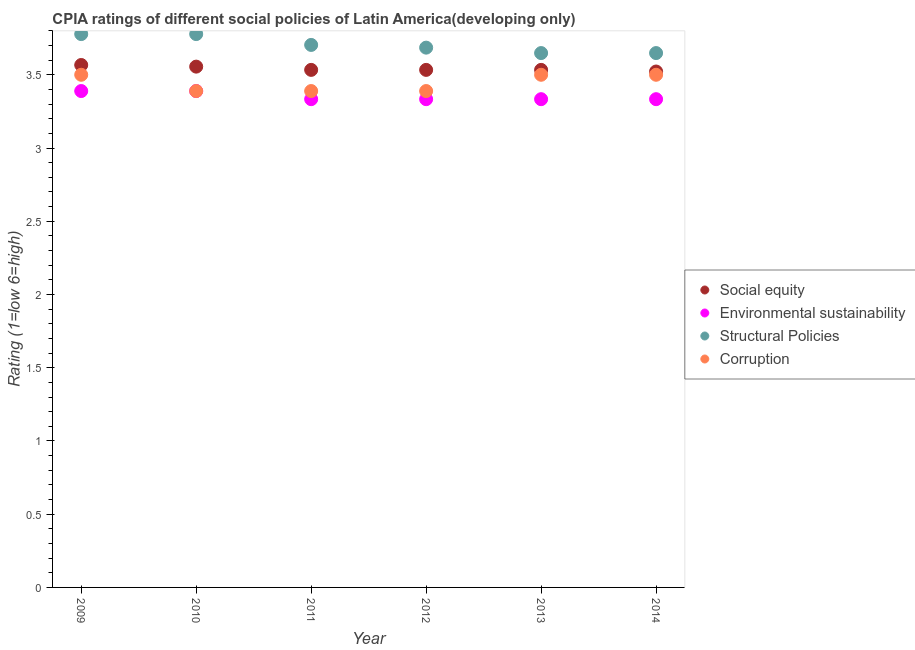Is the number of dotlines equal to the number of legend labels?
Give a very brief answer. Yes. Across all years, what is the maximum cpia rating of corruption?
Give a very brief answer. 3.5. Across all years, what is the minimum cpia rating of structural policies?
Keep it short and to the point. 3.65. In which year was the cpia rating of corruption minimum?
Provide a short and direct response. 2010. What is the total cpia rating of environmental sustainability in the graph?
Offer a terse response. 20.11. What is the difference between the cpia rating of social equity in 2012 and the cpia rating of environmental sustainability in 2009?
Ensure brevity in your answer.  0.14. What is the average cpia rating of social equity per year?
Give a very brief answer. 3.54. In the year 2012, what is the difference between the cpia rating of environmental sustainability and cpia rating of social equity?
Offer a very short reply. -0.2. What is the ratio of the cpia rating of structural policies in 2011 to that in 2013?
Offer a very short reply. 1.02. Is the difference between the cpia rating of corruption in 2012 and 2014 greater than the difference between the cpia rating of social equity in 2012 and 2014?
Your answer should be compact. No. What is the difference between the highest and the second highest cpia rating of corruption?
Your answer should be compact. 0. What is the difference between the highest and the lowest cpia rating of environmental sustainability?
Give a very brief answer. 0.06. In how many years, is the cpia rating of corruption greater than the average cpia rating of corruption taken over all years?
Offer a terse response. 3. Is the sum of the cpia rating of social equity in 2010 and 2011 greater than the maximum cpia rating of structural policies across all years?
Your response must be concise. Yes. Is it the case that in every year, the sum of the cpia rating of structural policies and cpia rating of environmental sustainability is greater than the sum of cpia rating of corruption and cpia rating of social equity?
Give a very brief answer. No. Is it the case that in every year, the sum of the cpia rating of social equity and cpia rating of environmental sustainability is greater than the cpia rating of structural policies?
Make the answer very short. Yes. Is the cpia rating of corruption strictly greater than the cpia rating of social equity over the years?
Ensure brevity in your answer.  No. Is the cpia rating of corruption strictly less than the cpia rating of environmental sustainability over the years?
Offer a very short reply. No. How many years are there in the graph?
Your answer should be very brief. 6. What is the difference between two consecutive major ticks on the Y-axis?
Provide a succinct answer. 0.5. Are the values on the major ticks of Y-axis written in scientific E-notation?
Offer a very short reply. No. How many legend labels are there?
Offer a terse response. 4. What is the title of the graph?
Provide a short and direct response. CPIA ratings of different social policies of Latin America(developing only). Does "United Kingdom" appear as one of the legend labels in the graph?
Keep it short and to the point. No. What is the Rating (1=low 6=high) in Social equity in 2009?
Your answer should be compact. 3.57. What is the Rating (1=low 6=high) in Environmental sustainability in 2009?
Give a very brief answer. 3.39. What is the Rating (1=low 6=high) of Structural Policies in 2009?
Your response must be concise. 3.78. What is the Rating (1=low 6=high) of Social equity in 2010?
Give a very brief answer. 3.56. What is the Rating (1=low 6=high) of Environmental sustainability in 2010?
Keep it short and to the point. 3.39. What is the Rating (1=low 6=high) of Structural Policies in 2010?
Give a very brief answer. 3.78. What is the Rating (1=low 6=high) in Corruption in 2010?
Give a very brief answer. 3.39. What is the Rating (1=low 6=high) in Social equity in 2011?
Your answer should be very brief. 3.53. What is the Rating (1=low 6=high) of Environmental sustainability in 2011?
Your answer should be compact. 3.33. What is the Rating (1=low 6=high) in Structural Policies in 2011?
Ensure brevity in your answer.  3.7. What is the Rating (1=low 6=high) of Corruption in 2011?
Provide a succinct answer. 3.39. What is the Rating (1=low 6=high) in Social equity in 2012?
Give a very brief answer. 3.53. What is the Rating (1=low 6=high) of Environmental sustainability in 2012?
Your answer should be compact. 3.33. What is the Rating (1=low 6=high) in Structural Policies in 2012?
Give a very brief answer. 3.69. What is the Rating (1=low 6=high) of Corruption in 2012?
Your answer should be compact. 3.39. What is the Rating (1=low 6=high) of Social equity in 2013?
Make the answer very short. 3.53. What is the Rating (1=low 6=high) in Environmental sustainability in 2013?
Your answer should be compact. 3.33. What is the Rating (1=low 6=high) in Structural Policies in 2013?
Keep it short and to the point. 3.65. What is the Rating (1=low 6=high) in Corruption in 2013?
Offer a terse response. 3.5. What is the Rating (1=low 6=high) in Social equity in 2014?
Offer a very short reply. 3.52. What is the Rating (1=low 6=high) of Environmental sustainability in 2014?
Make the answer very short. 3.33. What is the Rating (1=low 6=high) of Structural Policies in 2014?
Ensure brevity in your answer.  3.65. Across all years, what is the maximum Rating (1=low 6=high) in Social equity?
Your response must be concise. 3.57. Across all years, what is the maximum Rating (1=low 6=high) of Environmental sustainability?
Provide a short and direct response. 3.39. Across all years, what is the maximum Rating (1=low 6=high) in Structural Policies?
Ensure brevity in your answer.  3.78. Across all years, what is the maximum Rating (1=low 6=high) in Corruption?
Your answer should be very brief. 3.5. Across all years, what is the minimum Rating (1=low 6=high) of Social equity?
Provide a succinct answer. 3.52. Across all years, what is the minimum Rating (1=low 6=high) of Environmental sustainability?
Your answer should be compact. 3.33. Across all years, what is the minimum Rating (1=low 6=high) of Structural Policies?
Your response must be concise. 3.65. Across all years, what is the minimum Rating (1=low 6=high) in Corruption?
Your response must be concise. 3.39. What is the total Rating (1=low 6=high) of Social equity in the graph?
Provide a short and direct response. 21.24. What is the total Rating (1=low 6=high) in Environmental sustainability in the graph?
Give a very brief answer. 20.11. What is the total Rating (1=low 6=high) of Structural Policies in the graph?
Give a very brief answer. 22.24. What is the total Rating (1=low 6=high) of Corruption in the graph?
Make the answer very short. 20.67. What is the difference between the Rating (1=low 6=high) of Social equity in 2009 and that in 2010?
Your response must be concise. 0.01. What is the difference between the Rating (1=low 6=high) in Structural Policies in 2009 and that in 2010?
Offer a terse response. 0. What is the difference between the Rating (1=low 6=high) in Corruption in 2009 and that in 2010?
Keep it short and to the point. 0.11. What is the difference between the Rating (1=low 6=high) in Social equity in 2009 and that in 2011?
Ensure brevity in your answer.  0.03. What is the difference between the Rating (1=low 6=high) in Environmental sustainability in 2009 and that in 2011?
Your answer should be very brief. 0.06. What is the difference between the Rating (1=low 6=high) of Structural Policies in 2009 and that in 2011?
Make the answer very short. 0.07. What is the difference between the Rating (1=low 6=high) of Social equity in 2009 and that in 2012?
Your response must be concise. 0.03. What is the difference between the Rating (1=low 6=high) in Environmental sustainability in 2009 and that in 2012?
Offer a very short reply. 0.06. What is the difference between the Rating (1=low 6=high) in Structural Policies in 2009 and that in 2012?
Ensure brevity in your answer.  0.09. What is the difference between the Rating (1=low 6=high) of Environmental sustainability in 2009 and that in 2013?
Provide a short and direct response. 0.06. What is the difference between the Rating (1=low 6=high) in Structural Policies in 2009 and that in 2013?
Your answer should be very brief. 0.13. What is the difference between the Rating (1=low 6=high) in Social equity in 2009 and that in 2014?
Ensure brevity in your answer.  0.04. What is the difference between the Rating (1=low 6=high) in Environmental sustainability in 2009 and that in 2014?
Give a very brief answer. 0.06. What is the difference between the Rating (1=low 6=high) of Structural Policies in 2009 and that in 2014?
Give a very brief answer. 0.13. What is the difference between the Rating (1=low 6=high) of Corruption in 2009 and that in 2014?
Offer a terse response. 0. What is the difference between the Rating (1=low 6=high) of Social equity in 2010 and that in 2011?
Offer a terse response. 0.02. What is the difference between the Rating (1=low 6=high) of Environmental sustainability in 2010 and that in 2011?
Make the answer very short. 0.06. What is the difference between the Rating (1=low 6=high) in Structural Policies in 2010 and that in 2011?
Provide a short and direct response. 0.07. What is the difference between the Rating (1=low 6=high) of Corruption in 2010 and that in 2011?
Your response must be concise. 0. What is the difference between the Rating (1=low 6=high) of Social equity in 2010 and that in 2012?
Your response must be concise. 0.02. What is the difference between the Rating (1=low 6=high) of Environmental sustainability in 2010 and that in 2012?
Provide a succinct answer. 0.06. What is the difference between the Rating (1=low 6=high) in Structural Policies in 2010 and that in 2012?
Give a very brief answer. 0.09. What is the difference between the Rating (1=low 6=high) of Corruption in 2010 and that in 2012?
Provide a succinct answer. 0. What is the difference between the Rating (1=low 6=high) in Social equity in 2010 and that in 2013?
Make the answer very short. 0.02. What is the difference between the Rating (1=low 6=high) of Environmental sustainability in 2010 and that in 2013?
Keep it short and to the point. 0.06. What is the difference between the Rating (1=low 6=high) in Structural Policies in 2010 and that in 2013?
Ensure brevity in your answer.  0.13. What is the difference between the Rating (1=low 6=high) of Corruption in 2010 and that in 2013?
Offer a very short reply. -0.11. What is the difference between the Rating (1=low 6=high) of Environmental sustainability in 2010 and that in 2014?
Provide a succinct answer. 0.06. What is the difference between the Rating (1=low 6=high) in Structural Policies in 2010 and that in 2014?
Your answer should be very brief. 0.13. What is the difference between the Rating (1=low 6=high) of Corruption in 2010 and that in 2014?
Provide a succinct answer. -0.11. What is the difference between the Rating (1=low 6=high) in Structural Policies in 2011 and that in 2012?
Ensure brevity in your answer.  0.02. What is the difference between the Rating (1=low 6=high) in Social equity in 2011 and that in 2013?
Offer a terse response. 0. What is the difference between the Rating (1=low 6=high) of Structural Policies in 2011 and that in 2013?
Provide a short and direct response. 0.06. What is the difference between the Rating (1=low 6=high) in Corruption in 2011 and that in 2013?
Keep it short and to the point. -0.11. What is the difference between the Rating (1=low 6=high) in Social equity in 2011 and that in 2014?
Your response must be concise. 0.01. What is the difference between the Rating (1=low 6=high) of Structural Policies in 2011 and that in 2014?
Offer a very short reply. 0.06. What is the difference between the Rating (1=low 6=high) of Corruption in 2011 and that in 2014?
Your answer should be very brief. -0.11. What is the difference between the Rating (1=low 6=high) in Environmental sustainability in 2012 and that in 2013?
Your answer should be very brief. 0. What is the difference between the Rating (1=low 6=high) of Structural Policies in 2012 and that in 2013?
Keep it short and to the point. 0.04. What is the difference between the Rating (1=low 6=high) of Corruption in 2012 and that in 2013?
Your response must be concise. -0.11. What is the difference between the Rating (1=low 6=high) of Social equity in 2012 and that in 2014?
Keep it short and to the point. 0.01. What is the difference between the Rating (1=low 6=high) of Structural Policies in 2012 and that in 2014?
Keep it short and to the point. 0.04. What is the difference between the Rating (1=low 6=high) in Corruption in 2012 and that in 2014?
Your answer should be very brief. -0.11. What is the difference between the Rating (1=low 6=high) of Social equity in 2013 and that in 2014?
Offer a very short reply. 0.01. What is the difference between the Rating (1=low 6=high) in Environmental sustainability in 2013 and that in 2014?
Offer a terse response. 0. What is the difference between the Rating (1=low 6=high) of Corruption in 2013 and that in 2014?
Offer a terse response. 0. What is the difference between the Rating (1=low 6=high) in Social equity in 2009 and the Rating (1=low 6=high) in Environmental sustainability in 2010?
Provide a short and direct response. 0.18. What is the difference between the Rating (1=low 6=high) of Social equity in 2009 and the Rating (1=low 6=high) of Structural Policies in 2010?
Your answer should be compact. -0.21. What is the difference between the Rating (1=low 6=high) of Social equity in 2009 and the Rating (1=low 6=high) of Corruption in 2010?
Offer a very short reply. 0.18. What is the difference between the Rating (1=low 6=high) of Environmental sustainability in 2009 and the Rating (1=low 6=high) of Structural Policies in 2010?
Provide a succinct answer. -0.39. What is the difference between the Rating (1=low 6=high) in Structural Policies in 2009 and the Rating (1=low 6=high) in Corruption in 2010?
Make the answer very short. 0.39. What is the difference between the Rating (1=low 6=high) in Social equity in 2009 and the Rating (1=low 6=high) in Environmental sustainability in 2011?
Make the answer very short. 0.23. What is the difference between the Rating (1=low 6=high) of Social equity in 2009 and the Rating (1=low 6=high) of Structural Policies in 2011?
Your response must be concise. -0.14. What is the difference between the Rating (1=low 6=high) in Social equity in 2009 and the Rating (1=low 6=high) in Corruption in 2011?
Keep it short and to the point. 0.18. What is the difference between the Rating (1=low 6=high) of Environmental sustainability in 2009 and the Rating (1=low 6=high) of Structural Policies in 2011?
Give a very brief answer. -0.31. What is the difference between the Rating (1=low 6=high) in Structural Policies in 2009 and the Rating (1=low 6=high) in Corruption in 2011?
Your response must be concise. 0.39. What is the difference between the Rating (1=low 6=high) in Social equity in 2009 and the Rating (1=low 6=high) in Environmental sustainability in 2012?
Offer a terse response. 0.23. What is the difference between the Rating (1=low 6=high) in Social equity in 2009 and the Rating (1=low 6=high) in Structural Policies in 2012?
Your answer should be very brief. -0.12. What is the difference between the Rating (1=low 6=high) in Social equity in 2009 and the Rating (1=low 6=high) in Corruption in 2012?
Provide a short and direct response. 0.18. What is the difference between the Rating (1=low 6=high) in Environmental sustainability in 2009 and the Rating (1=low 6=high) in Structural Policies in 2012?
Offer a very short reply. -0.3. What is the difference between the Rating (1=low 6=high) of Structural Policies in 2009 and the Rating (1=low 6=high) of Corruption in 2012?
Offer a very short reply. 0.39. What is the difference between the Rating (1=low 6=high) of Social equity in 2009 and the Rating (1=low 6=high) of Environmental sustainability in 2013?
Offer a terse response. 0.23. What is the difference between the Rating (1=low 6=high) of Social equity in 2009 and the Rating (1=low 6=high) of Structural Policies in 2013?
Offer a very short reply. -0.08. What is the difference between the Rating (1=low 6=high) of Social equity in 2009 and the Rating (1=low 6=high) of Corruption in 2013?
Your answer should be very brief. 0.07. What is the difference between the Rating (1=low 6=high) in Environmental sustainability in 2009 and the Rating (1=low 6=high) in Structural Policies in 2013?
Your response must be concise. -0.26. What is the difference between the Rating (1=low 6=high) of Environmental sustainability in 2009 and the Rating (1=low 6=high) of Corruption in 2013?
Provide a short and direct response. -0.11. What is the difference between the Rating (1=low 6=high) in Structural Policies in 2009 and the Rating (1=low 6=high) in Corruption in 2013?
Offer a terse response. 0.28. What is the difference between the Rating (1=low 6=high) of Social equity in 2009 and the Rating (1=low 6=high) of Environmental sustainability in 2014?
Keep it short and to the point. 0.23. What is the difference between the Rating (1=low 6=high) of Social equity in 2009 and the Rating (1=low 6=high) of Structural Policies in 2014?
Your response must be concise. -0.08. What is the difference between the Rating (1=low 6=high) in Social equity in 2009 and the Rating (1=low 6=high) in Corruption in 2014?
Ensure brevity in your answer.  0.07. What is the difference between the Rating (1=low 6=high) in Environmental sustainability in 2009 and the Rating (1=low 6=high) in Structural Policies in 2014?
Provide a succinct answer. -0.26. What is the difference between the Rating (1=low 6=high) of Environmental sustainability in 2009 and the Rating (1=low 6=high) of Corruption in 2014?
Your answer should be very brief. -0.11. What is the difference between the Rating (1=low 6=high) of Structural Policies in 2009 and the Rating (1=low 6=high) of Corruption in 2014?
Give a very brief answer. 0.28. What is the difference between the Rating (1=low 6=high) of Social equity in 2010 and the Rating (1=low 6=high) of Environmental sustainability in 2011?
Your answer should be very brief. 0.22. What is the difference between the Rating (1=low 6=high) of Social equity in 2010 and the Rating (1=low 6=high) of Structural Policies in 2011?
Ensure brevity in your answer.  -0.15. What is the difference between the Rating (1=low 6=high) of Social equity in 2010 and the Rating (1=low 6=high) of Corruption in 2011?
Provide a succinct answer. 0.17. What is the difference between the Rating (1=low 6=high) of Environmental sustainability in 2010 and the Rating (1=low 6=high) of Structural Policies in 2011?
Your answer should be compact. -0.31. What is the difference between the Rating (1=low 6=high) of Environmental sustainability in 2010 and the Rating (1=low 6=high) of Corruption in 2011?
Ensure brevity in your answer.  0. What is the difference between the Rating (1=low 6=high) in Structural Policies in 2010 and the Rating (1=low 6=high) in Corruption in 2011?
Your answer should be very brief. 0.39. What is the difference between the Rating (1=low 6=high) of Social equity in 2010 and the Rating (1=low 6=high) of Environmental sustainability in 2012?
Keep it short and to the point. 0.22. What is the difference between the Rating (1=low 6=high) of Social equity in 2010 and the Rating (1=low 6=high) of Structural Policies in 2012?
Your response must be concise. -0.13. What is the difference between the Rating (1=low 6=high) of Environmental sustainability in 2010 and the Rating (1=low 6=high) of Structural Policies in 2012?
Give a very brief answer. -0.3. What is the difference between the Rating (1=low 6=high) of Structural Policies in 2010 and the Rating (1=low 6=high) of Corruption in 2012?
Keep it short and to the point. 0.39. What is the difference between the Rating (1=low 6=high) of Social equity in 2010 and the Rating (1=low 6=high) of Environmental sustainability in 2013?
Provide a short and direct response. 0.22. What is the difference between the Rating (1=low 6=high) in Social equity in 2010 and the Rating (1=low 6=high) in Structural Policies in 2013?
Keep it short and to the point. -0.09. What is the difference between the Rating (1=low 6=high) of Social equity in 2010 and the Rating (1=low 6=high) of Corruption in 2013?
Give a very brief answer. 0.06. What is the difference between the Rating (1=low 6=high) of Environmental sustainability in 2010 and the Rating (1=low 6=high) of Structural Policies in 2013?
Ensure brevity in your answer.  -0.26. What is the difference between the Rating (1=low 6=high) of Environmental sustainability in 2010 and the Rating (1=low 6=high) of Corruption in 2013?
Offer a very short reply. -0.11. What is the difference between the Rating (1=low 6=high) in Structural Policies in 2010 and the Rating (1=low 6=high) in Corruption in 2013?
Make the answer very short. 0.28. What is the difference between the Rating (1=low 6=high) of Social equity in 2010 and the Rating (1=low 6=high) of Environmental sustainability in 2014?
Ensure brevity in your answer.  0.22. What is the difference between the Rating (1=low 6=high) in Social equity in 2010 and the Rating (1=low 6=high) in Structural Policies in 2014?
Provide a succinct answer. -0.09. What is the difference between the Rating (1=low 6=high) in Social equity in 2010 and the Rating (1=low 6=high) in Corruption in 2014?
Provide a succinct answer. 0.06. What is the difference between the Rating (1=low 6=high) in Environmental sustainability in 2010 and the Rating (1=low 6=high) in Structural Policies in 2014?
Provide a succinct answer. -0.26. What is the difference between the Rating (1=low 6=high) in Environmental sustainability in 2010 and the Rating (1=low 6=high) in Corruption in 2014?
Make the answer very short. -0.11. What is the difference between the Rating (1=low 6=high) of Structural Policies in 2010 and the Rating (1=low 6=high) of Corruption in 2014?
Offer a very short reply. 0.28. What is the difference between the Rating (1=low 6=high) of Social equity in 2011 and the Rating (1=low 6=high) of Structural Policies in 2012?
Your response must be concise. -0.15. What is the difference between the Rating (1=low 6=high) of Social equity in 2011 and the Rating (1=low 6=high) of Corruption in 2012?
Your answer should be compact. 0.14. What is the difference between the Rating (1=low 6=high) of Environmental sustainability in 2011 and the Rating (1=low 6=high) of Structural Policies in 2012?
Your response must be concise. -0.35. What is the difference between the Rating (1=low 6=high) in Environmental sustainability in 2011 and the Rating (1=low 6=high) in Corruption in 2012?
Make the answer very short. -0.06. What is the difference between the Rating (1=low 6=high) of Structural Policies in 2011 and the Rating (1=low 6=high) of Corruption in 2012?
Provide a succinct answer. 0.31. What is the difference between the Rating (1=low 6=high) in Social equity in 2011 and the Rating (1=low 6=high) in Structural Policies in 2013?
Offer a very short reply. -0.11. What is the difference between the Rating (1=low 6=high) of Social equity in 2011 and the Rating (1=low 6=high) of Corruption in 2013?
Ensure brevity in your answer.  0.03. What is the difference between the Rating (1=low 6=high) of Environmental sustainability in 2011 and the Rating (1=low 6=high) of Structural Policies in 2013?
Give a very brief answer. -0.31. What is the difference between the Rating (1=low 6=high) of Structural Policies in 2011 and the Rating (1=low 6=high) of Corruption in 2013?
Your answer should be very brief. 0.2. What is the difference between the Rating (1=low 6=high) in Social equity in 2011 and the Rating (1=low 6=high) in Environmental sustainability in 2014?
Make the answer very short. 0.2. What is the difference between the Rating (1=low 6=high) of Social equity in 2011 and the Rating (1=low 6=high) of Structural Policies in 2014?
Keep it short and to the point. -0.11. What is the difference between the Rating (1=low 6=high) in Social equity in 2011 and the Rating (1=low 6=high) in Corruption in 2014?
Make the answer very short. 0.03. What is the difference between the Rating (1=low 6=high) of Environmental sustainability in 2011 and the Rating (1=low 6=high) of Structural Policies in 2014?
Offer a terse response. -0.31. What is the difference between the Rating (1=low 6=high) in Structural Policies in 2011 and the Rating (1=low 6=high) in Corruption in 2014?
Keep it short and to the point. 0.2. What is the difference between the Rating (1=low 6=high) of Social equity in 2012 and the Rating (1=low 6=high) of Structural Policies in 2013?
Keep it short and to the point. -0.11. What is the difference between the Rating (1=low 6=high) of Social equity in 2012 and the Rating (1=low 6=high) of Corruption in 2013?
Your answer should be very brief. 0.03. What is the difference between the Rating (1=low 6=high) of Environmental sustainability in 2012 and the Rating (1=low 6=high) of Structural Policies in 2013?
Your answer should be compact. -0.31. What is the difference between the Rating (1=low 6=high) in Environmental sustainability in 2012 and the Rating (1=low 6=high) in Corruption in 2013?
Your answer should be compact. -0.17. What is the difference between the Rating (1=low 6=high) in Structural Policies in 2012 and the Rating (1=low 6=high) in Corruption in 2013?
Make the answer very short. 0.19. What is the difference between the Rating (1=low 6=high) of Social equity in 2012 and the Rating (1=low 6=high) of Structural Policies in 2014?
Provide a succinct answer. -0.11. What is the difference between the Rating (1=low 6=high) of Social equity in 2012 and the Rating (1=low 6=high) of Corruption in 2014?
Offer a terse response. 0.03. What is the difference between the Rating (1=low 6=high) in Environmental sustainability in 2012 and the Rating (1=low 6=high) in Structural Policies in 2014?
Provide a succinct answer. -0.31. What is the difference between the Rating (1=low 6=high) in Structural Policies in 2012 and the Rating (1=low 6=high) in Corruption in 2014?
Give a very brief answer. 0.19. What is the difference between the Rating (1=low 6=high) of Social equity in 2013 and the Rating (1=low 6=high) of Environmental sustainability in 2014?
Your answer should be very brief. 0.2. What is the difference between the Rating (1=low 6=high) in Social equity in 2013 and the Rating (1=low 6=high) in Structural Policies in 2014?
Ensure brevity in your answer.  -0.11. What is the difference between the Rating (1=low 6=high) of Environmental sustainability in 2013 and the Rating (1=low 6=high) of Structural Policies in 2014?
Keep it short and to the point. -0.31. What is the difference between the Rating (1=low 6=high) in Structural Policies in 2013 and the Rating (1=low 6=high) in Corruption in 2014?
Provide a short and direct response. 0.15. What is the average Rating (1=low 6=high) in Social equity per year?
Your response must be concise. 3.54. What is the average Rating (1=low 6=high) in Environmental sustainability per year?
Ensure brevity in your answer.  3.35. What is the average Rating (1=low 6=high) in Structural Policies per year?
Your answer should be very brief. 3.71. What is the average Rating (1=low 6=high) in Corruption per year?
Your answer should be compact. 3.44. In the year 2009, what is the difference between the Rating (1=low 6=high) of Social equity and Rating (1=low 6=high) of Environmental sustainability?
Offer a very short reply. 0.18. In the year 2009, what is the difference between the Rating (1=low 6=high) of Social equity and Rating (1=low 6=high) of Structural Policies?
Your answer should be very brief. -0.21. In the year 2009, what is the difference between the Rating (1=low 6=high) in Social equity and Rating (1=low 6=high) in Corruption?
Provide a succinct answer. 0.07. In the year 2009, what is the difference between the Rating (1=low 6=high) of Environmental sustainability and Rating (1=low 6=high) of Structural Policies?
Your answer should be very brief. -0.39. In the year 2009, what is the difference between the Rating (1=low 6=high) in Environmental sustainability and Rating (1=low 6=high) in Corruption?
Make the answer very short. -0.11. In the year 2009, what is the difference between the Rating (1=low 6=high) of Structural Policies and Rating (1=low 6=high) of Corruption?
Provide a succinct answer. 0.28. In the year 2010, what is the difference between the Rating (1=low 6=high) in Social equity and Rating (1=low 6=high) in Environmental sustainability?
Provide a succinct answer. 0.17. In the year 2010, what is the difference between the Rating (1=low 6=high) in Social equity and Rating (1=low 6=high) in Structural Policies?
Your response must be concise. -0.22. In the year 2010, what is the difference between the Rating (1=low 6=high) of Social equity and Rating (1=low 6=high) of Corruption?
Offer a terse response. 0.17. In the year 2010, what is the difference between the Rating (1=low 6=high) of Environmental sustainability and Rating (1=low 6=high) of Structural Policies?
Make the answer very short. -0.39. In the year 2010, what is the difference between the Rating (1=low 6=high) of Environmental sustainability and Rating (1=low 6=high) of Corruption?
Your response must be concise. 0. In the year 2010, what is the difference between the Rating (1=low 6=high) of Structural Policies and Rating (1=low 6=high) of Corruption?
Your answer should be very brief. 0.39. In the year 2011, what is the difference between the Rating (1=low 6=high) in Social equity and Rating (1=low 6=high) in Structural Policies?
Ensure brevity in your answer.  -0.17. In the year 2011, what is the difference between the Rating (1=low 6=high) of Social equity and Rating (1=low 6=high) of Corruption?
Offer a terse response. 0.14. In the year 2011, what is the difference between the Rating (1=low 6=high) in Environmental sustainability and Rating (1=low 6=high) in Structural Policies?
Your answer should be compact. -0.37. In the year 2011, what is the difference between the Rating (1=low 6=high) of Environmental sustainability and Rating (1=low 6=high) of Corruption?
Provide a short and direct response. -0.06. In the year 2011, what is the difference between the Rating (1=low 6=high) in Structural Policies and Rating (1=low 6=high) in Corruption?
Keep it short and to the point. 0.31. In the year 2012, what is the difference between the Rating (1=low 6=high) of Social equity and Rating (1=low 6=high) of Structural Policies?
Give a very brief answer. -0.15. In the year 2012, what is the difference between the Rating (1=low 6=high) in Social equity and Rating (1=low 6=high) in Corruption?
Your answer should be compact. 0.14. In the year 2012, what is the difference between the Rating (1=low 6=high) of Environmental sustainability and Rating (1=low 6=high) of Structural Policies?
Offer a very short reply. -0.35. In the year 2012, what is the difference between the Rating (1=low 6=high) of Environmental sustainability and Rating (1=low 6=high) of Corruption?
Provide a succinct answer. -0.06. In the year 2012, what is the difference between the Rating (1=low 6=high) in Structural Policies and Rating (1=low 6=high) in Corruption?
Your answer should be compact. 0.3. In the year 2013, what is the difference between the Rating (1=low 6=high) in Social equity and Rating (1=low 6=high) in Environmental sustainability?
Provide a short and direct response. 0.2. In the year 2013, what is the difference between the Rating (1=low 6=high) in Social equity and Rating (1=low 6=high) in Structural Policies?
Offer a very short reply. -0.11. In the year 2013, what is the difference between the Rating (1=low 6=high) in Environmental sustainability and Rating (1=low 6=high) in Structural Policies?
Make the answer very short. -0.31. In the year 2013, what is the difference between the Rating (1=low 6=high) of Structural Policies and Rating (1=low 6=high) of Corruption?
Your response must be concise. 0.15. In the year 2014, what is the difference between the Rating (1=low 6=high) in Social equity and Rating (1=low 6=high) in Environmental sustainability?
Make the answer very short. 0.19. In the year 2014, what is the difference between the Rating (1=low 6=high) of Social equity and Rating (1=low 6=high) of Structural Policies?
Your answer should be very brief. -0.13. In the year 2014, what is the difference between the Rating (1=low 6=high) in Social equity and Rating (1=low 6=high) in Corruption?
Provide a short and direct response. 0.02. In the year 2014, what is the difference between the Rating (1=low 6=high) in Environmental sustainability and Rating (1=low 6=high) in Structural Policies?
Offer a very short reply. -0.31. In the year 2014, what is the difference between the Rating (1=low 6=high) in Environmental sustainability and Rating (1=low 6=high) in Corruption?
Make the answer very short. -0.17. In the year 2014, what is the difference between the Rating (1=low 6=high) in Structural Policies and Rating (1=low 6=high) in Corruption?
Provide a succinct answer. 0.15. What is the ratio of the Rating (1=low 6=high) of Social equity in 2009 to that in 2010?
Offer a terse response. 1. What is the ratio of the Rating (1=low 6=high) of Corruption in 2009 to that in 2010?
Make the answer very short. 1.03. What is the ratio of the Rating (1=low 6=high) of Social equity in 2009 to that in 2011?
Your answer should be very brief. 1.01. What is the ratio of the Rating (1=low 6=high) of Environmental sustainability in 2009 to that in 2011?
Offer a terse response. 1.02. What is the ratio of the Rating (1=low 6=high) in Corruption in 2009 to that in 2011?
Your answer should be very brief. 1.03. What is the ratio of the Rating (1=low 6=high) in Social equity in 2009 to that in 2012?
Make the answer very short. 1.01. What is the ratio of the Rating (1=low 6=high) of Environmental sustainability in 2009 to that in 2012?
Ensure brevity in your answer.  1.02. What is the ratio of the Rating (1=low 6=high) of Structural Policies in 2009 to that in 2012?
Give a very brief answer. 1.03. What is the ratio of the Rating (1=low 6=high) of Corruption in 2009 to that in 2012?
Provide a succinct answer. 1.03. What is the ratio of the Rating (1=low 6=high) of Social equity in 2009 to that in 2013?
Offer a very short reply. 1.01. What is the ratio of the Rating (1=low 6=high) in Environmental sustainability in 2009 to that in 2013?
Your response must be concise. 1.02. What is the ratio of the Rating (1=low 6=high) in Structural Policies in 2009 to that in 2013?
Make the answer very short. 1.04. What is the ratio of the Rating (1=low 6=high) in Corruption in 2009 to that in 2013?
Your answer should be very brief. 1. What is the ratio of the Rating (1=low 6=high) of Social equity in 2009 to that in 2014?
Your answer should be compact. 1.01. What is the ratio of the Rating (1=low 6=high) of Environmental sustainability in 2009 to that in 2014?
Provide a short and direct response. 1.02. What is the ratio of the Rating (1=low 6=high) of Structural Policies in 2009 to that in 2014?
Ensure brevity in your answer.  1.04. What is the ratio of the Rating (1=low 6=high) of Social equity in 2010 to that in 2011?
Give a very brief answer. 1.01. What is the ratio of the Rating (1=low 6=high) of Environmental sustainability in 2010 to that in 2011?
Give a very brief answer. 1.02. What is the ratio of the Rating (1=low 6=high) in Corruption in 2010 to that in 2011?
Provide a succinct answer. 1. What is the ratio of the Rating (1=low 6=high) in Social equity in 2010 to that in 2012?
Ensure brevity in your answer.  1.01. What is the ratio of the Rating (1=low 6=high) of Environmental sustainability in 2010 to that in 2012?
Offer a terse response. 1.02. What is the ratio of the Rating (1=low 6=high) of Structural Policies in 2010 to that in 2012?
Your answer should be very brief. 1.03. What is the ratio of the Rating (1=low 6=high) of Corruption in 2010 to that in 2012?
Provide a succinct answer. 1. What is the ratio of the Rating (1=low 6=high) in Environmental sustainability in 2010 to that in 2013?
Provide a succinct answer. 1.02. What is the ratio of the Rating (1=low 6=high) in Structural Policies in 2010 to that in 2013?
Your response must be concise. 1.04. What is the ratio of the Rating (1=low 6=high) in Corruption in 2010 to that in 2013?
Offer a terse response. 0.97. What is the ratio of the Rating (1=low 6=high) of Social equity in 2010 to that in 2014?
Give a very brief answer. 1.01. What is the ratio of the Rating (1=low 6=high) of Environmental sustainability in 2010 to that in 2014?
Provide a succinct answer. 1.02. What is the ratio of the Rating (1=low 6=high) of Structural Policies in 2010 to that in 2014?
Your response must be concise. 1.04. What is the ratio of the Rating (1=low 6=high) of Corruption in 2010 to that in 2014?
Your answer should be very brief. 0.97. What is the ratio of the Rating (1=low 6=high) of Structural Policies in 2011 to that in 2012?
Offer a very short reply. 1. What is the ratio of the Rating (1=low 6=high) of Corruption in 2011 to that in 2012?
Keep it short and to the point. 1. What is the ratio of the Rating (1=low 6=high) of Social equity in 2011 to that in 2013?
Offer a terse response. 1. What is the ratio of the Rating (1=low 6=high) of Structural Policies in 2011 to that in 2013?
Provide a short and direct response. 1.02. What is the ratio of the Rating (1=low 6=high) of Corruption in 2011 to that in 2013?
Offer a terse response. 0.97. What is the ratio of the Rating (1=low 6=high) in Structural Policies in 2011 to that in 2014?
Ensure brevity in your answer.  1.02. What is the ratio of the Rating (1=low 6=high) of Corruption in 2011 to that in 2014?
Your response must be concise. 0.97. What is the ratio of the Rating (1=low 6=high) of Social equity in 2012 to that in 2013?
Give a very brief answer. 1. What is the ratio of the Rating (1=low 6=high) in Environmental sustainability in 2012 to that in 2013?
Ensure brevity in your answer.  1. What is the ratio of the Rating (1=low 6=high) in Structural Policies in 2012 to that in 2013?
Provide a short and direct response. 1.01. What is the ratio of the Rating (1=low 6=high) in Corruption in 2012 to that in 2013?
Offer a terse response. 0.97. What is the ratio of the Rating (1=low 6=high) of Environmental sustainability in 2012 to that in 2014?
Offer a terse response. 1. What is the ratio of the Rating (1=low 6=high) in Structural Policies in 2012 to that in 2014?
Offer a terse response. 1.01. What is the ratio of the Rating (1=low 6=high) of Corruption in 2012 to that in 2014?
Your response must be concise. 0.97. What is the difference between the highest and the second highest Rating (1=low 6=high) of Social equity?
Make the answer very short. 0.01. What is the difference between the highest and the second highest Rating (1=low 6=high) of Structural Policies?
Give a very brief answer. 0. What is the difference between the highest and the second highest Rating (1=low 6=high) in Corruption?
Provide a short and direct response. 0. What is the difference between the highest and the lowest Rating (1=low 6=high) in Social equity?
Ensure brevity in your answer.  0.04. What is the difference between the highest and the lowest Rating (1=low 6=high) in Environmental sustainability?
Your response must be concise. 0.06. What is the difference between the highest and the lowest Rating (1=low 6=high) in Structural Policies?
Keep it short and to the point. 0.13. 